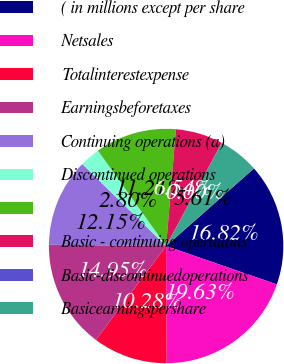Convert chart to OTSL. <chart><loc_0><loc_0><loc_500><loc_500><pie_chart><fcel>( in millions except per share<fcel>Netsales<fcel>Totalinterestexpense<fcel>Earningsbeforetaxes<fcel>Continuing operations (a)<fcel>Discontinued operations<fcel>Unnamed: 6<fcel>Basic - continuing operations<fcel>Basic-discontinuedoperations<fcel>Basicearningspershare<nl><fcel>16.82%<fcel>19.63%<fcel>10.28%<fcel>14.95%<fcel>12.15%<fcel>2.8%<fcel>11.21%<fcel>6.54%<fcel>0.0%<fcel>5.61%<nl></chart> 